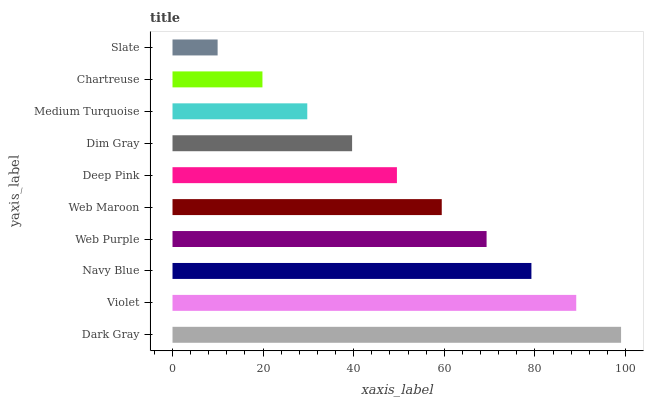Is Slate the minimum?
Answer yes or no. Yes. Is Dark Gray the maximum?
Answer yes or no. Yes. Is Violet the minimum?
Answer yes or no. No. Is Violet the maximum?
Answer yes or no. No. Is Dark Gray greater than Violet?
Answer yes or no. Yes. Is Violet less than Dark Gray?
Answer yes or no. Yes. Is Violet greater than Dark Gray?
Answer yes or no. No. Is Dark Gray less than Violet?
Answer yes or no. No. Is Web Maroon the high median?
Answer yes or no. Yes. Is Deep Pink the low median?
Answer yes or no. Yes. Is Navy Blue the high median?
Answer yes or no. No. Is Violet the low median?
Answer yes or no. No. 